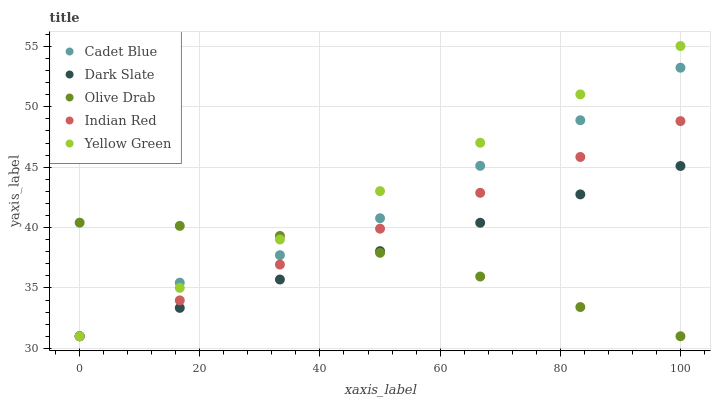Does Olive Drab have the minimum area under the curve?
Answer yes or no. Yes. Does Yellow Green have the maximum area under the curve?
Answer yes or no. Yes. Does Cadet Blue have the minimum area under the curve?
Answer yes or no. No. Does Cadet Blue have the maximum area under the curve?
Answer yes or no. No. Is Indian Red the smoothest?
Answer yes or no. Yes. Is Cadet Blue the roughest?
Answer yes or no. Yes. Is Cadet Blue the smoothest?
Answer yes or no. No. Is Indian Red the roughest?
Answer yes or no. No. Does Dark Slate have the lowest value?
Answer yes or no. Yes. Does Yellow Green have the highest value?
Answer yes or no. Yes. Does Cadet Blue have the highest value?
Answer yes or no. No. Does Cadet Blue intersect Yellow Green?
Answer yes or no. Yes. Is Cadet Blue less than Yellow Green?
Answer yes or no. No. Is Cadet Blue greater than Yellow Green?
Answer yes or no. No. 